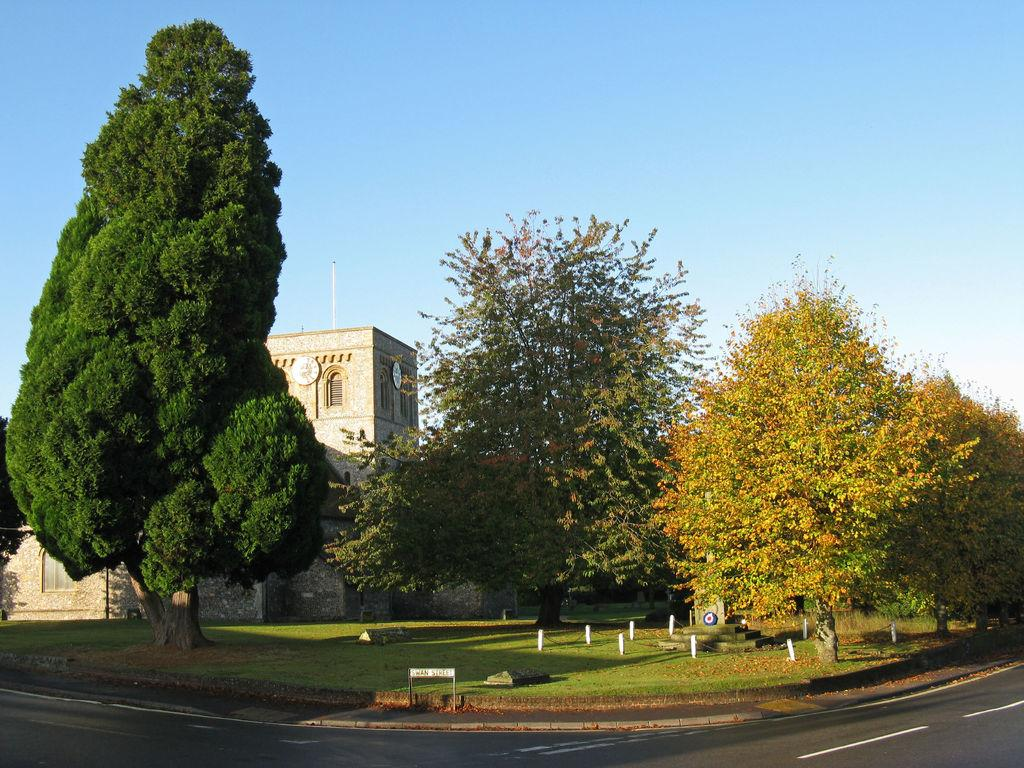What type of vegetation is present in the image? There are trees and grass in the image. What can be seen on the ground in the image? There are shadows and white lines on the road in the image. What type of structure is visible in the image? There is a building in the image. What is visible in the background of the image? The sky is visible in the background of the image. Can you describe the thrill experienced by the stranger in the image? There is no stranger present in the image, so it is not possible to describe any thrill experienced by them. 